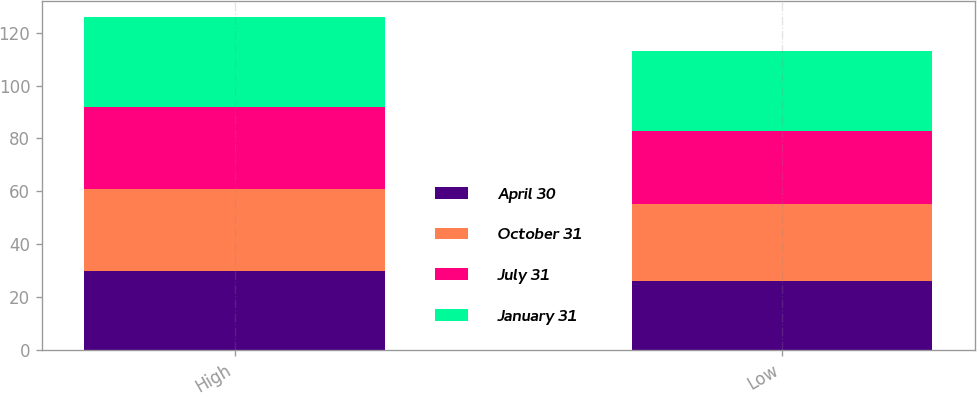Convert chart to OTSL. <chart><loc_0><loc_0><loc_500><loc_500><stacked_bar_chart><ecel><fcel>High<fcel>Low<nl><fcel>April 30<fcel>29.63<fcel>26.1<nl><fcel>October 31<fcel>31.04<fcel>29.06<nl><fcel>July 31<fcel>31.07<fcel>27.49<nl><fcel>January 31<fcel>34.1<fcel>30.29<nl></chart> 